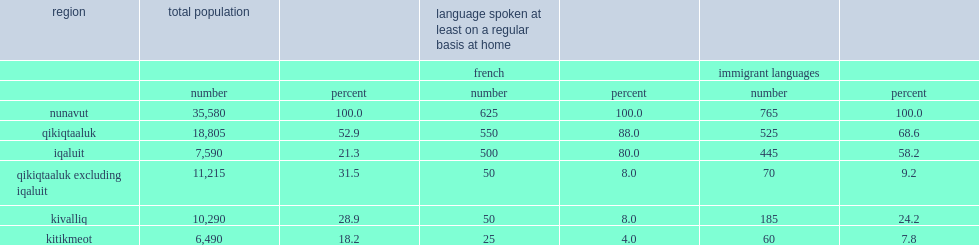Would you mind parsing the complete table? {'header': ['region', 'total population', '', 'language spoken at least on a regular basis at home', '', '', ''], 'rows': [['', '', '', 'french', '', 'immigrant languages', ''], ['', 'number', 'percent', 'number', 'percent', 'number', 'percent'], ['nunavut', '35,580', '100.0', '625', '100.0', '765', '100.0'], ['qikiqtaaluk', '18,805', '52.9', '550', '88.0', '525', '68.6'], ['iqaluit', '7,590', '21.3', '500', '80.0', '445', '58.2'], ['qikiqtaaluk excluding iqaluit', '11,215', '31.5', '50', '8.0', '70', '9.2'], ['kivalliq', '10,290', '28.9', '50', '8.0', '185', '24.2'], ['kitikmeot', '6,490', '18.2', '25', '4.0', '60', '7.8']]} How many people who use french at home in nunavut? 625.0. Of the 625 people who use french at home in nunavut, how mnay people live in iqaluit? 500.0. Of the 625 people who use french at home in nunavut, what was the percent of people live in iqaluit? 80.0. In relation to nunavut's total population, the rate of geographic concentration is very high; what was the percent of nunavut's total population was living in iqaluit in 2016? 21.3. In 2016, what was the percent of those who spoke an immigrant language were living in iqaluit? 58.2. 